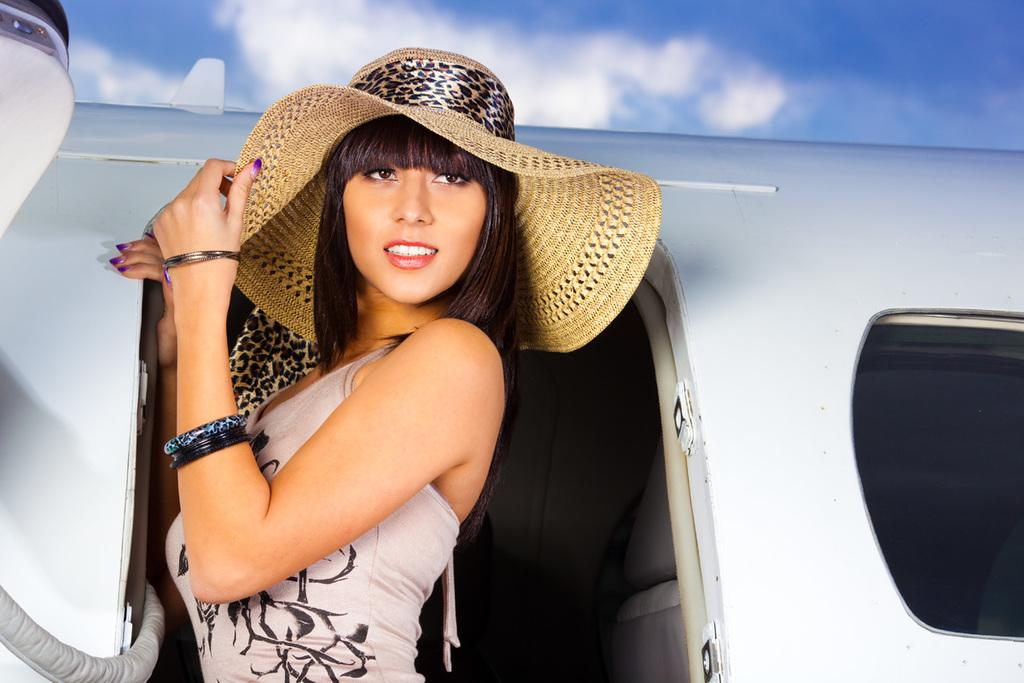What is the main subject of the image? There is a woman standing in the image. What can be seen in the background of the image? There is a sky with clouds visible in the background of the image. What country is the woman visiting, as indicated by the ticket in her hand in the image? There is no ticket visible in the woman's hand in the image, and therefore no indication of which country she might be visiting. Is there any smoke visible in the image? There is no smoke present in the image. 